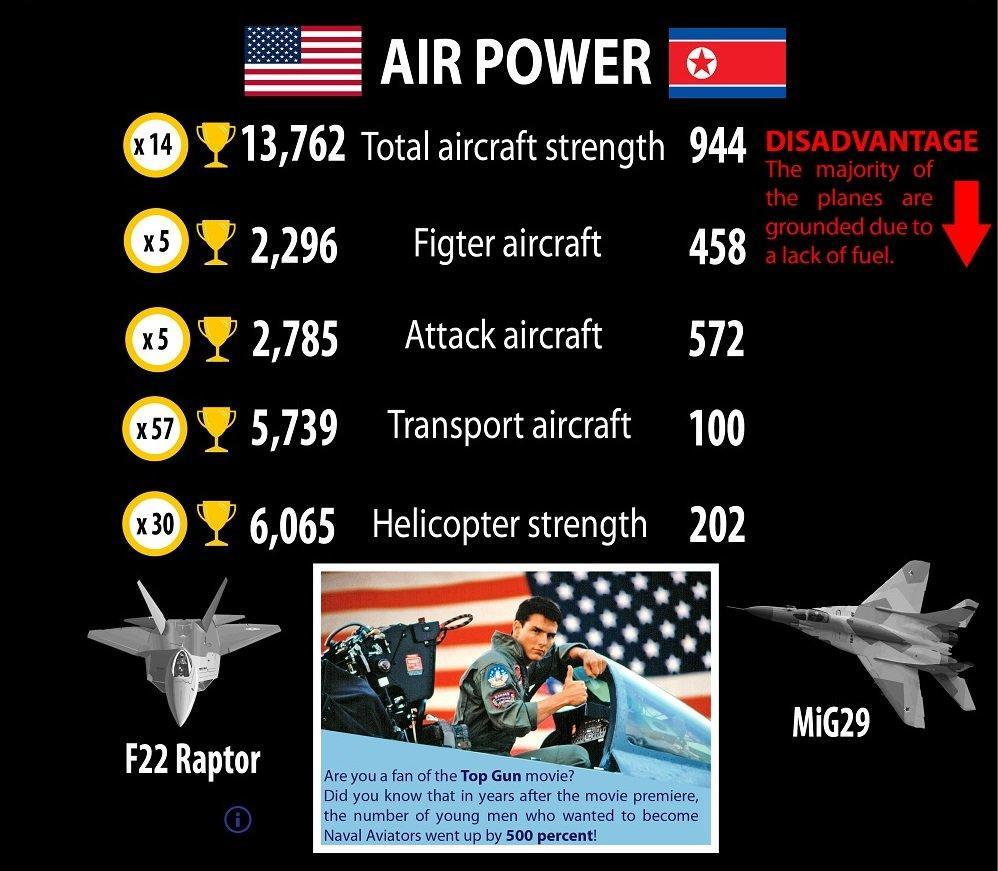How many fighter aircrafts of America are listed?
Answer the question with a short phrase. 2 Which are the major fighter aircrafts of America? F22 Raptor, MiG29 